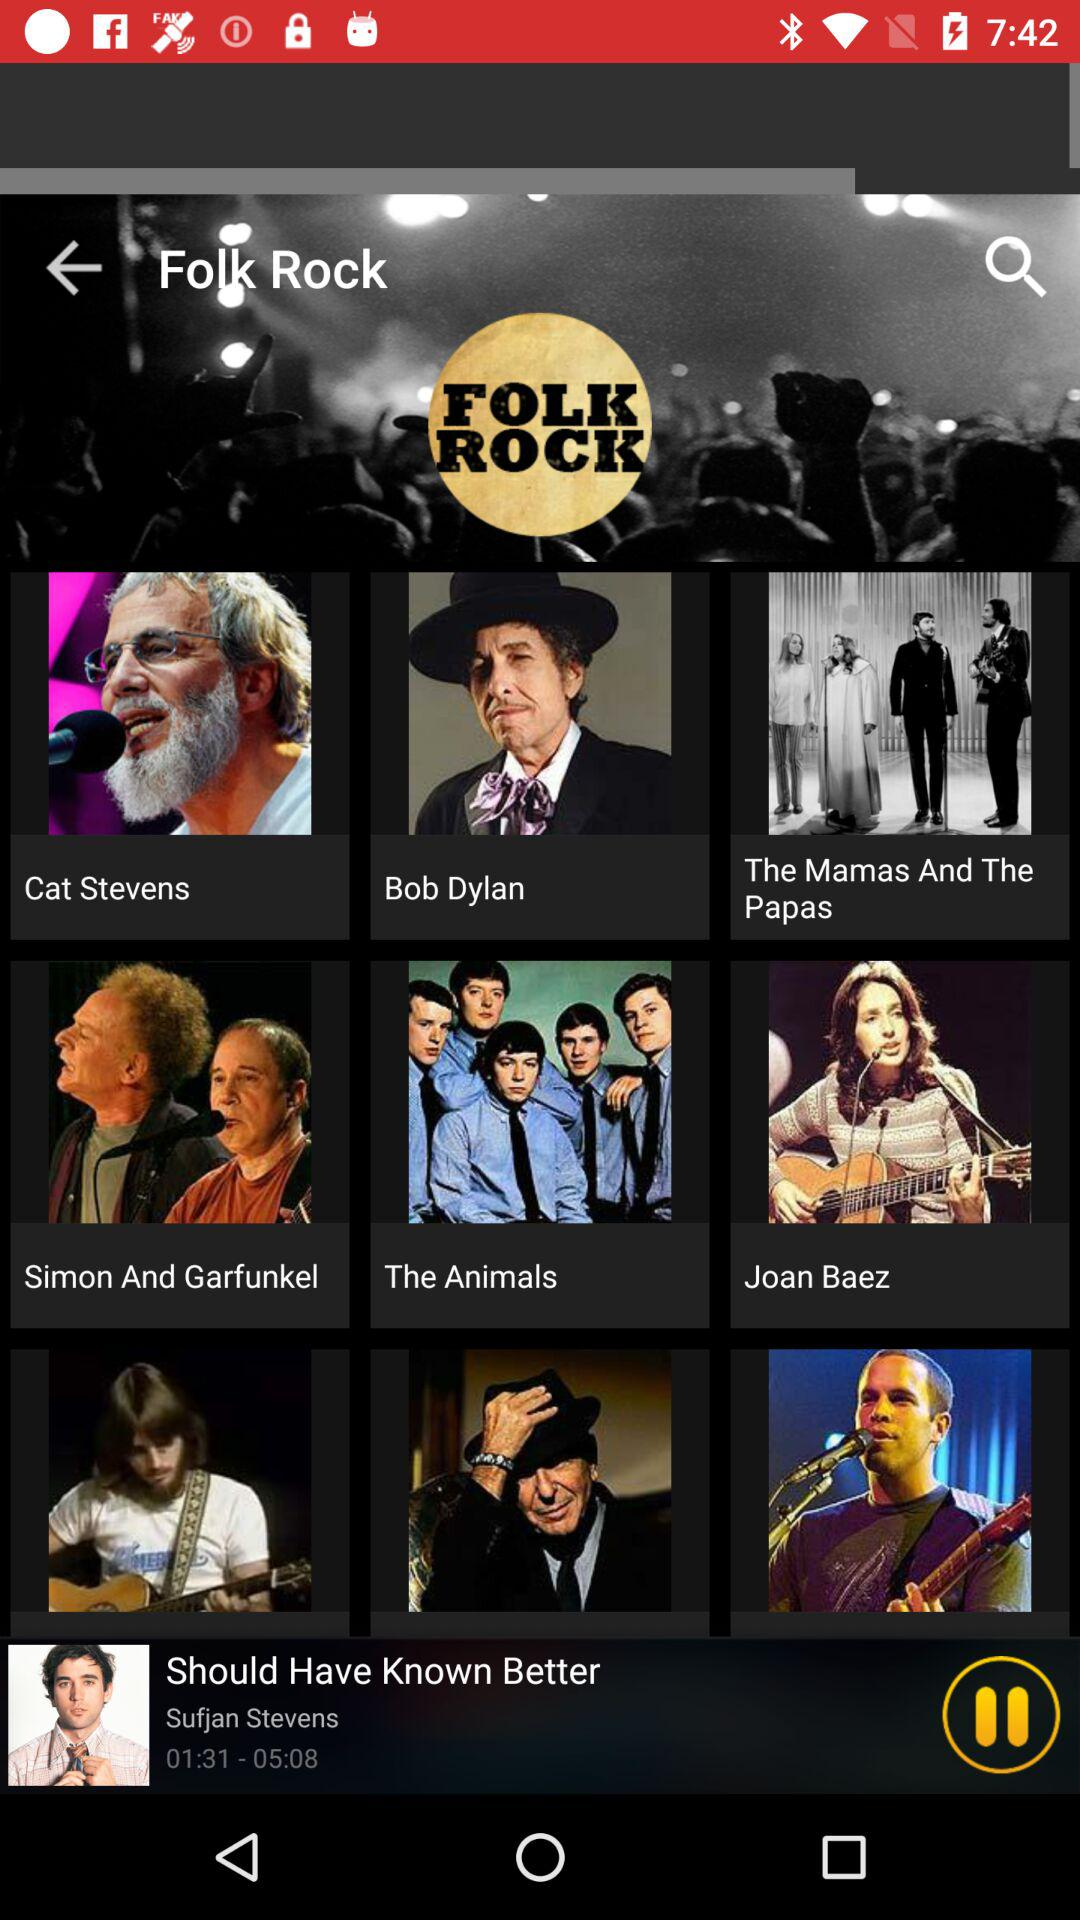Which song is playing? The song "Should Have Known Better" is playing. 